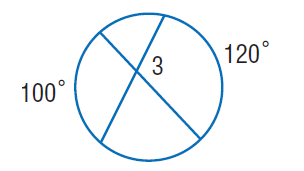Question: Find \angle 3.
Choices:
A. 100
B. 110
C. 120
D. 220
Answer with the letter. Answer: B 